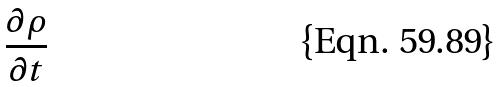Convert formula to latex. <formula><loc_0><loc_0><loc_500><loc_500>\frac { \partial \rho } { \partial t }</formula> 